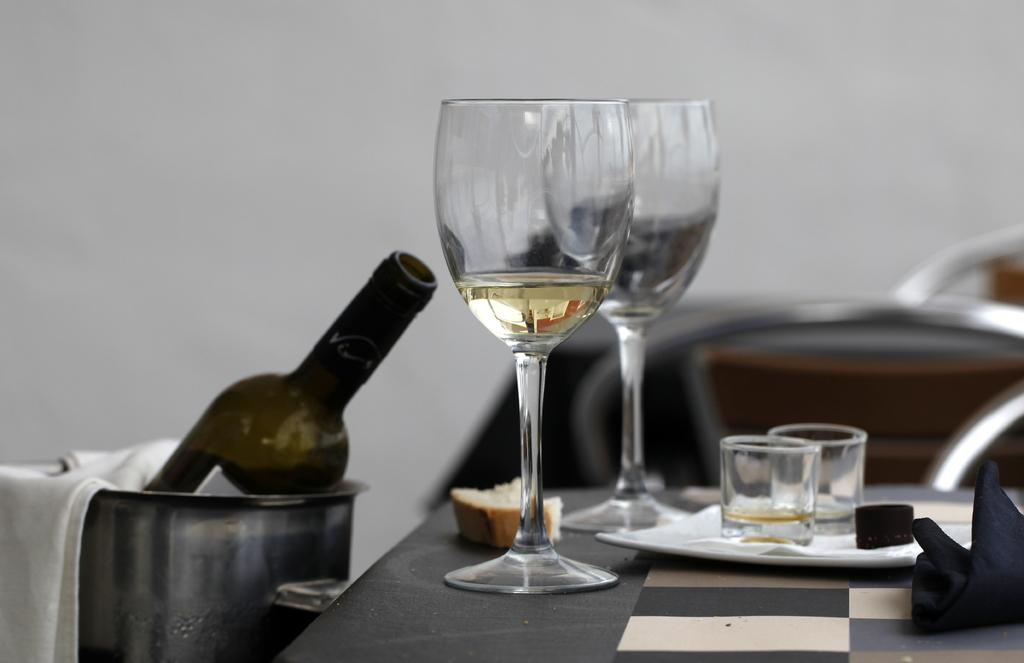How many wine glasses are visible in the image? There are two wine glasses in the image. What else can be seen on the table in the image? There is a plate in the image. What might be used to pour liquid into the wine glasses? There is a bottle in the image. What type of horn can be seen in the image? There is no horn present in the image. Is there a monkey sitting on the table in the image? No, there is no monkey present in the image. 